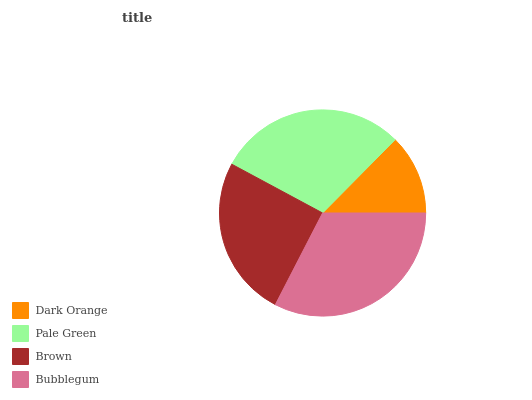Is Dark Orange the minimum?
Answer yes or no. Yes. Is Bubblegum the maximum?
Answer yes or no. Yes. Is Pale Green the minimum?
Answer yes or no. No. Is Pale Green the maximum?
Answer yes or no. No. Is Pale Green greater than Dark Orange?
Answer yes or no. Yes. Is Dark Orange less than Pale Green?
Answer yes or no. Yes. Is Dark Orange greater than Pale Green?
Answer yes or no. No. Is Pale Green less than Dark Orange?
Answer yes or no. No. Is Pale Green the high median?
Answer yes or no. Yes. Is Brown the low median?
Answer yes or no. Yes. Is Dark Orange the high median?
Answer yes or no. No. Is Bubblegum the low median?
Answer yes or no. No. 